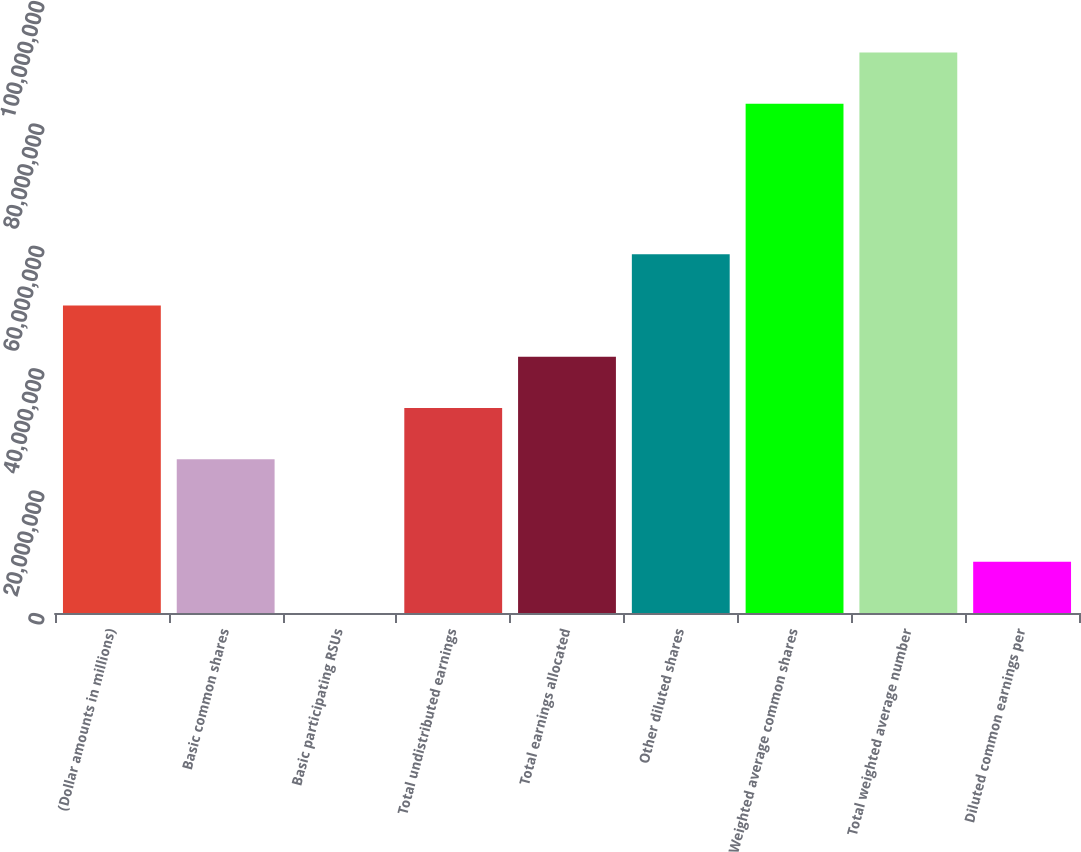Convert chart. <chart><loc_0><loc_0><loc_500><loc_500><bar_chart><fcel>(Dollar amounts in millions)<fcel>Basic common shares<fcel>Basic participating RSUs<fcel>Total undistributed earnings<fcel>Total earnings allocated<fcel>Other diluted shares<fcel>Weighted average common shares<fcel>Total weighted average number<fcel>Diluted common earnings per<nl><fcel>5.02393e+07<fcel>2.51197e+07<fcel>1<fcel>3.34929e+07<fcel>4.18661e+07<fcel>5.86126e+07<fcel>8.32065e+07<fcel>9.15797e+07<fcel>8.37322e+06<nl></chart> 